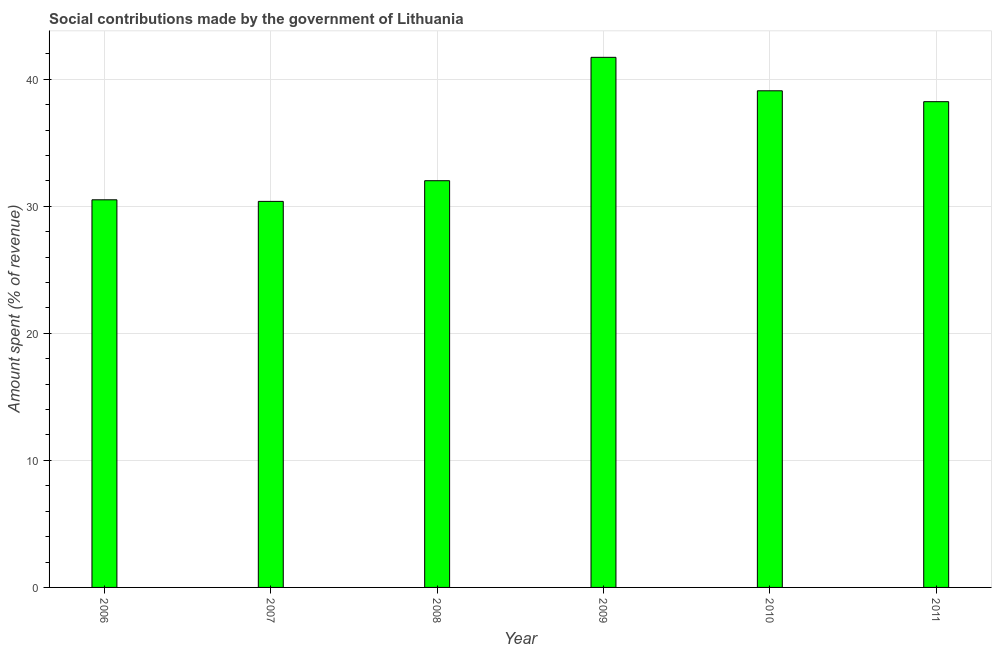Does the graph contain grids?
Provide a short and direct response. Yes. What is the title of the graph?
Your answer should be compact. Social contributions made by the government of Lithuania. What is the label or title of the X-axis?
Provide a succinct answer. Year. What is the label or title of the Y-axis?
Give a very brief answer. Amount spent (% of revenue). What is the amount spent in making social contributions in 2009?
Give a very brief answer. 41.72. Across all years, what is the maximum amount spent in making social contributions?
Keep it short and to the point. 41.72. Across all years, what is the minimum amount spent in making social contributions?
Provide a short and direct response. 30.38. In which year was the amount spent in making social contributions maximum?
Your response must be concise. 2009. In which year was the amount spent in making social contributions minimum?
Ensure brevity in your answer.  2007. What is the sum of the amount spent in making social contributions?
Offer a terse response. 211.94. What is the difference between the amount spent in making social contributions in 2007 and 2011?
Offer a very short reply. -7.85. What is the average amount spent in making social contributions per year?
Keep it short and to the point. 35.32. What is the median amount spent in making social contributions?
Offer a terse response. 35.12. In how many years, is the amount spent in making social contributions greater than 2 %?
Keep it short and to the point. 6. Do a majority of the years between 2010 and 2007 (inclusive) have amount spent in making social contributions greater than 14 %?
Your answer should be compact. Yes. What is the ratio of the amount spent in making social contributions in 2007 to that in 2009?
Keep it short and to the point. 0.73. Is the amount spent in making social contributions in 2008 less than that in 2010?
Your response must be concise. Yes. Is the difference between the amount spent in making social contributions in 2009 and 2010 greater than the difference between any two years?
Ensure brevity in your answer.  No. What is the difference between the highest and the second highest amount spent in making social contributions?
Offer a very short reply. 2.63. Is the sum of the amount spent in making social contributions in 2006 and 2008 greater than the maximum amount spent in making social contributions across all years?
Ensure brevity in your answer.  Yes. What is the difference between the highest and the lowest amount spent in making social contributions?
Offer a terse response. 11.34. In how many years, is the amount spent in making social contributions greater than the average amount spent in making social contributions taken over all years?
Offer a terse response. 3. How many years are there in the graph?
Give a very brief answer. 6. What is the difference between two consecutive major ticks on the Y-axis?
Your answer should be very brief. 10. Are the values on the major ticks of Y-axis written in scientific E-notation?
Your response must be concise. No. What is the Amount spent (% of revenue) of 2006?
Keep it short and to the point. 30.51. What is the Amount spent (% of revenue) of 2007?
Give a very brief answer. 30.38. What is the Amount spent (% of revenue) in 2008?
Ensure brevity in your answer.  32.01. What is the Amount spent (% of revenue) of 2009?
Ensure brevity in your answer.  41.72. What is the Amount spent (% of revenue) in 2010?
Provide a succinct answer. 39.09. What is the Amount spent (% of revenue) of 2011?
Make the answer very short. 38.23. What is the difference between the Amount spent (% of revenue) in 2006 and 2007?
Provide a succinct answer. 0.12. What is the difference between the Amount spent (% of revenue) in 2006 and 2008?
Provide a short and direct response. -1.5. What is the difference between the Amount spent (% of revenue) in 2006 and 2009?
Provide a short and direct response. -11.21. What is the difference between the Amount spent (% of revenue) in 2006 and 2010?
Offer a terse response. -8.58. What is the difference between the Amount spent (% of revenue) in 2006 and 2011?
Your answer should be compact. -7.72. What is the difference between the Amount spent (% of revenue) in 2007 and 2008?
Give a very brief answer. -1.63. What is the difference between the Amount spent (% of revenue) in 2007 and 2009?
Your answer should be compact. -11.34. What is the difference between the Amount spent (% of revenue) in 2007 and 2010?
Ensure brevity in your answer.  -8.7. What is the difference between the Amount spent (% of revenue) in 2007 and 2011?
Provide a succinct answer. -7.85. What is the difference between the Amount spent (% of revenue) in 2008 and 2009?
Your answer should be compact. -9.71. What is the difference between the Amount spent (% of revenue) in 2008 and 2010?
Give a very brief answer. -7.08. What is the difference between the Amount spent (% of revenue) in 2008 and 2011?
Provide a succinct answer. -6.22. What is the difference between the Amount spent (% of revenue) in 2009 and 2010?
Offer a very short reply. 2.63. What is the difference between the Amount spent (% of revenue) in 2009 and 2011?
Make the answer very short. 3.49. What is the difference between the Amount spent (% of revenue) in 2010 and 2011?
Your answer should be compact. 0.86. What is the ratio of the Amount spent (% of revenue) in 2006 to that in 2007?
Provide a succinct answer. 1. What is the ratio of the Amount spent (% of revenue) in 2006 to that in 2008?
Keep it short and to the point. 0.95. What is the ratio of the Amount spent (% of revenue) in 2006 to that in 2009?
Offer a very short reply. 0.73. What is the ratio of the Amount spent (% of revenue) in 2006 to that in 2010?
Your answer should be compact. 0.78. What is the ratio of the Amount spent (% of revenue) in 2006 to that in 2011?
Provide a succinct answer. 0.8. What is the ratio of the Amount spent (% of revenue) in 2007 to that in 2008?
Your answer should be very brief. 0.95. What is the ratio of the Amount spent (% of revenue) in 2007 to that in 2009?
Your answer should be very brief. 0.73. What is the ratio of the Amount spent (% of revenue) in 2007 to that in 2010?
Your response must be concise. 0.78. What is the ratio of the Amount spent (% of revenue) in 2007 to that in 2011?
Keep it short and to the point. 0.8. What is the ratio of the Amount spent (% of revenue) in 2008 to that in 2009?
Offer a very short reply. 0.77. What is the ratio of the Amount spent (% of revenue) in 2008 to that in 2010?
Give a very brief answer. 0.82. What is the ratio of the Amount spent (% of revenue) in 2008 to that in 2011?
Offer a very short reply. 0.84. What is the ratio of the Amount spent (% of revenue) in 2009 to that in 2010?
Your answer should be compact. 1.07. What is the ratio of the Amount spent (% of revenue) in 2009 to that in 2011?
Your answer should be very brief. 1.09. What is the ratio of the Amount spent (% of revenue) in 2010 to that in 2011?
Your answer should be very brief. 1.02. 